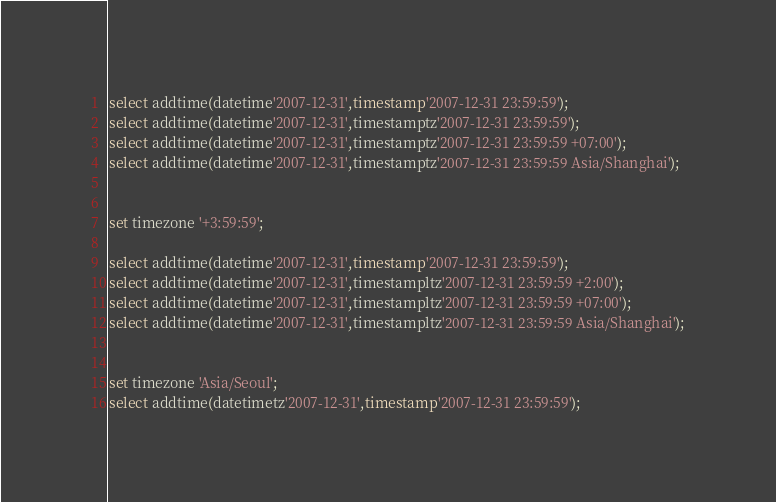<code> <loc_0><loc_0><loc_500><loc_500><_SQL_>select addtime(datetime'2007-12-31',timestamp'2007-12-31 23:59:59');
select addtime(datetime'2007-12-31',timestamptz'2007-12-31 23:59:59');
select addtime(datetime'2007-12-31',timestamptz'2007-12-31 23:59:59 +07:00');
select addtime(datetime'2007-12-31',timestamptz'2007-12-31 23:59:59 Asia/Shanghai');


set timezone '+3:59:59';

select addtime(datetime'2007-12-31',timestamp'2007-12-31 23:59:59');
select addtime(datetime'2007-12-31',timestampltz'2007-12-31 23:59:59 +2:00');
select addtime(datetime'2007-12-31',timestampltz'2007-12-31 23:59:59 +07:00');
select addtime(datetime'2007-12-31',timestampltz'2007-12-31 23:59:59 Asia/Shanghai');


set timezone 'Asia/Seoul';
select addtime(datetimetz'2007-12-31',timestamp'2007-12-31 23:59:59');</code> 